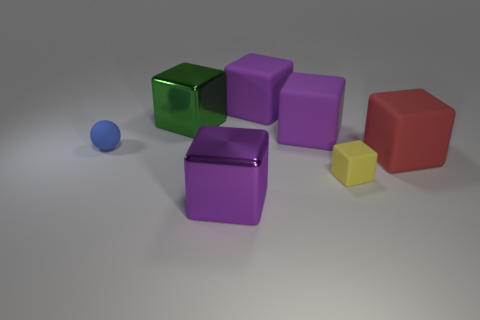Subtract all tiny blocks. How many blocks are left? 5 Add 2 tiny matte objects. How many objects exist? 9 Subtract 4 blocks. How many blocks are left? 2 Subtract all green cylinders. How many purple cubes are left? 3 Subtract all yellow cubes. How many cubes are left? 5 Subtract all cubes. How many objects are left? 1 Subtract 1 yellow blocks. How many objects are left? 6 Subtract all green balls. Subtract all cyan cylinders. How many balls are left? 1 Subtract all green metallic things. Subtract all purple matte cubes. How many objects are left? 4 Add 1 large purple shiny cubes. How many large purple shiny cubes are left? 2 